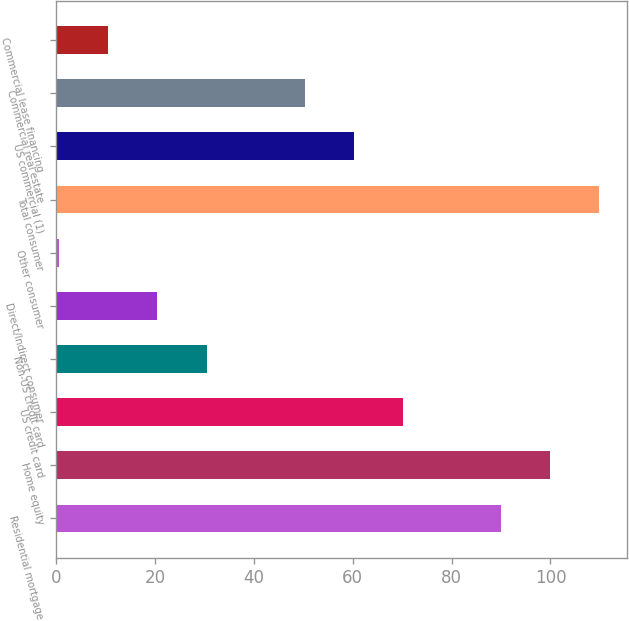<chart> <loc_0><loc_0><loc_500><loc_500><bar_chart><fcel>Residential mortgage<fcel>Home equity<fcel>US credit card<fcel>Non-US credit card<fcel>Direct/Indirect consumer<fcel>Other consumer<fcel>Total consumer<fcel>US commercial (1)<fcel>Commercial real estate<fcel>Commercial lease financing<nl><fcel>90.04<fcel>99.98<fcel>70.16<fcel>30.4<fcel>20.46<fcel>0.58<fcel>109.92<fcel>60.22<fcel>50.28<fcel>10.52<nl></chart> 